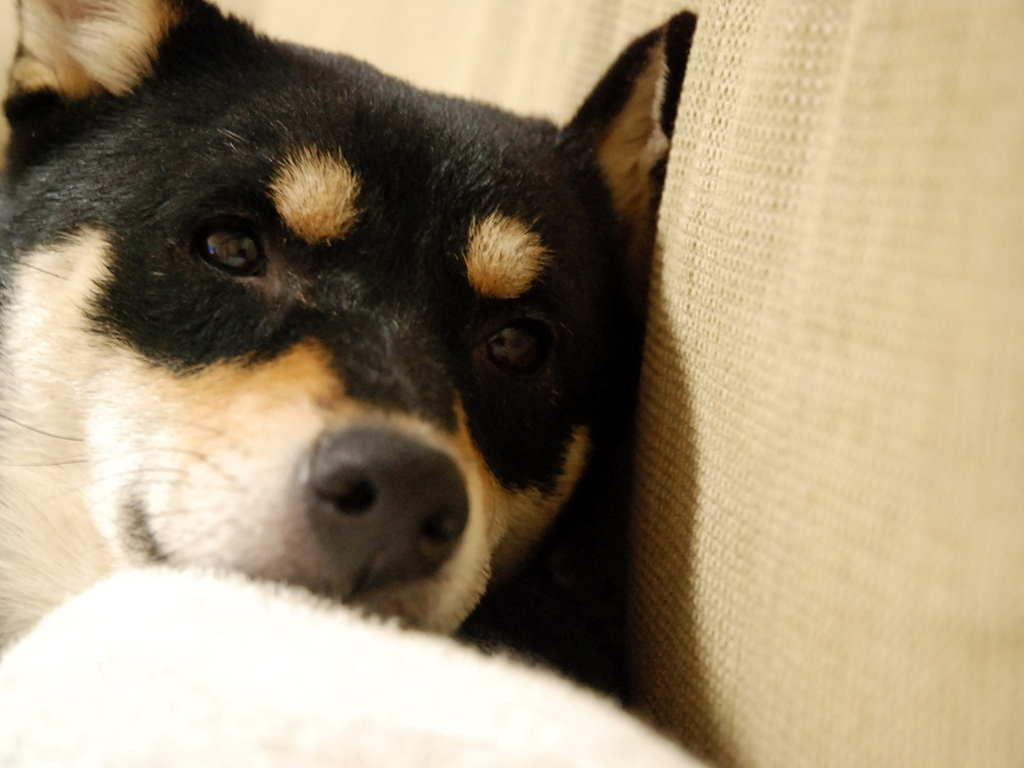What time of day do you think the photo was taken based on the lighting? Given the soft, diffused light on the dog's face and the overall warmth of the image, it suggests that the photo may have been taken during the golden hour, which is shortly after sunrise or before sunset when the sunlight is softer and warmer. 